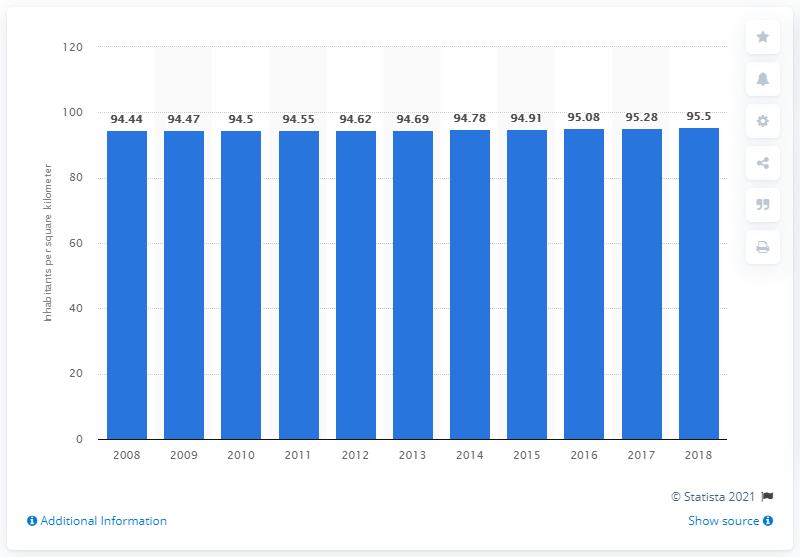Give some essential details in this illustration. In 2018, the population density of Dominica was 95.5 people per square kilometer. 